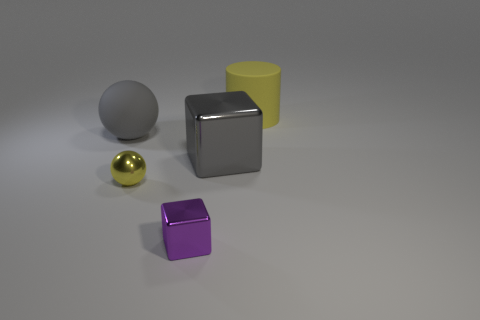There is a matte thing that is the same size as the yellow matte cylinder; what is its shape?
Ensure brevity in your answer.  Sphere. Are there any small purple metallic objects of the same shape as the large gray shiny thing?
Your answer should be very brief. Yes. Are the small purple cube and the large thing that is behind the big matte ball made of the same material?
Your answer should be very brief. No. There is a cube that is in front of the ball in front of the ball left of the small yellow thing; what color is it?
Give a very brief answer. Purple. What is the material of the gray ball that is the same size as the gray metallic object?
Your answer should be compact. Rubber. What number of balls have the same material as the purple cube?
Keep it short and to the point. 1. Do the rubber cylinder that is behind the tiny purple object and the ball in front of the big gray block have the same size?
Provide a short and direct response. No. What color is the small shiny object that is behind the small purple object?
Provide a succinct answer. Yellow. There is a big thing that is the same color as the shiny sphere; what is it made of?
Ensure brevity in your answer.  Rubber. How many large cubes have the same color as the large sphere?
Ensure brevity in your answer.  1. 